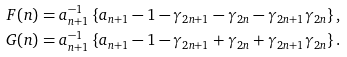Convert formula to latex. <formula><loc_0><loc_0><loc_500><loc_500>F ( n ) & = a _ { n + 1 } ^ { - 1 } \left \{ a _ { n + 1 } - 1 - \gamma _ { 2 n + 1 } - \gamma _ { 2 n } - \gamma _ { 2 n + 1 } \gamma _ { 2 n } \right \} , \\ G ( n ) & = a _ { n + 1 } ^ { - 1 } \left \{ a _ { n + 1 } - 1 - \gamma _ { 2 n + 1 } + \gamma _ { 2 n } + \gamma _ { 2 n + 1 } \gamma _ { 2 n } \right \} .</formula> 